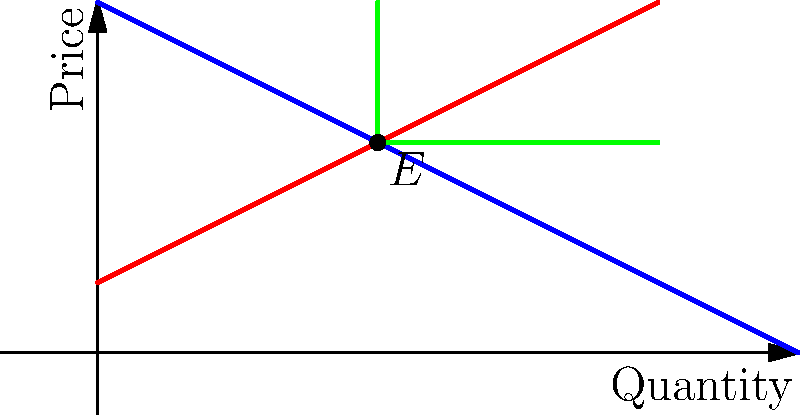In the context of Modern Monetary Theory, explain how the equilibrium point $E$ in this graph demonstrates the difference between vertical money (traditional view) and horizontal money (MMT view) in terms of supply and demand. To understand the difference between vertical and horizontal money using this graph:

1. Vertical money (traditional view):
   - Represented by blue supply curve $S_v$ and red demand curve $D_v$
   - Price (interest rate) adjusts to balance supply and demand
   - Quantity of money is considered fixed or controlled by central bank

2. Horizontal money (MMT view):
   - Represented by green lines $S_h$ and $D_h$
   - Quantity of money adjusts to meet demand at a given price (interest rate)
   - Price (interest rate) is set by monetary policy

3. Equilibrium point $E$:
   - Where vertical and horizontal views intersect
   - In vertical money: price adjusts to reach $E$
   - In horizontal money: quantity adjusts to reach $E$

4. MMT implications:
   - Government can always meet its financial obligations in its own currency
   - Interest rates are a policy choice, not market-determined
   - Focus shifts from "affordability" to real resource constraints and inflation

5. Policy perspective:
   - Vertical: monetary policy focuses on controlling money supply
   - Horizontal: monetary policy sets interest rates, fiscal policy determines money quantity

This graph illustrates how MMT challenges traditional views on money creation and monetary policy, emphasizing the endogenous nature of money supply.
Answer: Vertical money adjusts price to balance supply/demand; horizontal money adjusts quantity at policy-set price. 